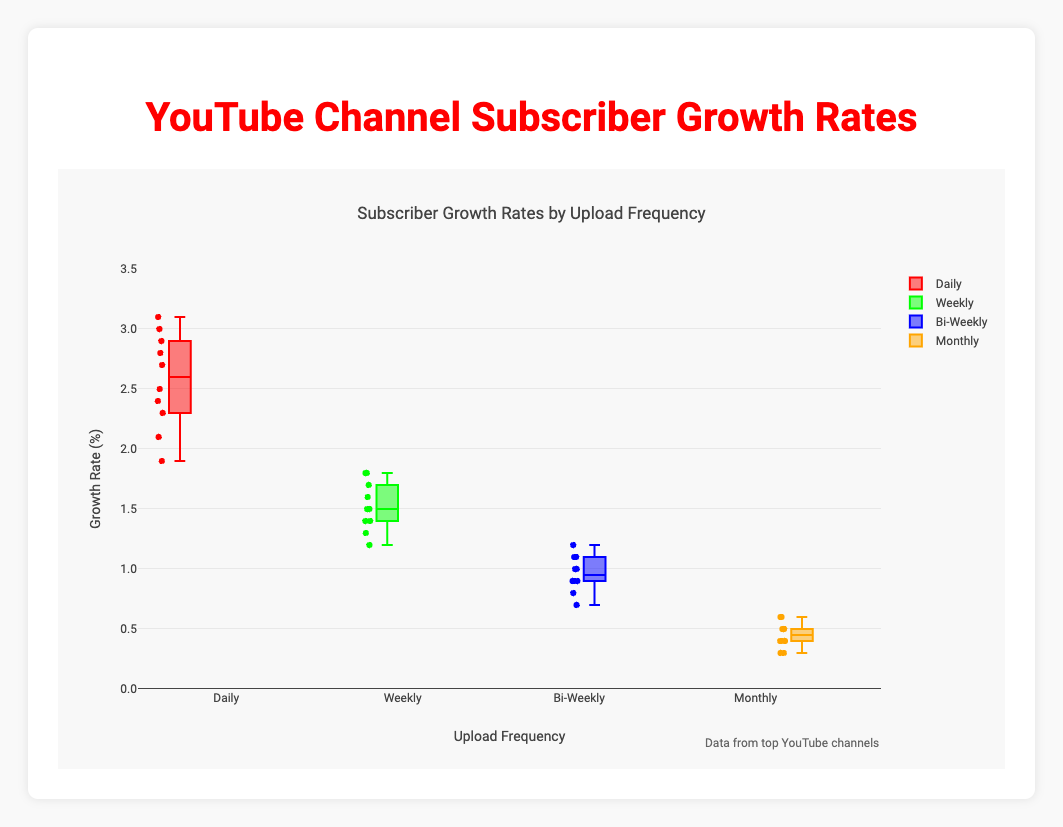What is the title of the figure? The title of the figure is displayed prominently at the top. It reads "Subscriber Growth Rates by Upload Frequency".
Answer: "Subscriber Growth Rates by Upload Frequency" How many different upload frequencies are represented in the box plot? The upload frequencies are represented along the x-axis. There are four: Daily, Weekly, Bi-Weekly, and Monthly.
Answer: Four Which upload frequency has the highest median growth rate? To determine the highest median growth rate, compare the central line within each box. The median for Daily is visibly higher than the others.
Answer: Daily What is the range of growth rates for the Monthly upload frequency? The range of growth rates is determined by the minimum and maximum values in the data set. For Monthly, it spans from 0.3% to 0.6% as shown by the lowest and highest points of the boxes and whiskers.
Answer: 0.3% to 0.6% What color represents the Weekly upload frequency in the box plot? The Weekly upload frequency is assigned a unique color for visualization. In this plot, it is represented by green.
Answer: Green Which upload frequency has the largest interquartile range (IQR)? The IQR can be determined by looking at the height of the box. The Daily upload frequency has a taller box compared to others, indicating a larger IQR.
Answer: Daily What is the median growth rate for the Bi-Weekly upload frequency? To find the median, look at the central line within the Bi-Weekly box. The median appears to be around 1.0%.
Answer: 1.0% How do the maximum growth rates of Weekly and Bi-Weekly upload frequencies compare? Compare the maximum points (top whiskers) of both Weekly and Bi-Weekly frequencies. The Weekly frequency's maximum is 1.8%, while Bi-Weekly's is 1.2%.
Answer: Weekly is higher What is the approximate growth rate of the most successful channel in the Daily upload category? Identify the highest point in the Daily category's box plot. The outlier, or highest point, is approximately 3.1%.
Answer: 3.1% Assuming Monthly frequency has the lowest lower quartile (Q1), what is its value? The lower quartile (Q1) is the bottom of the box. For Monthly, it appears to be at around 0.4%.
Answer: 0.4% 